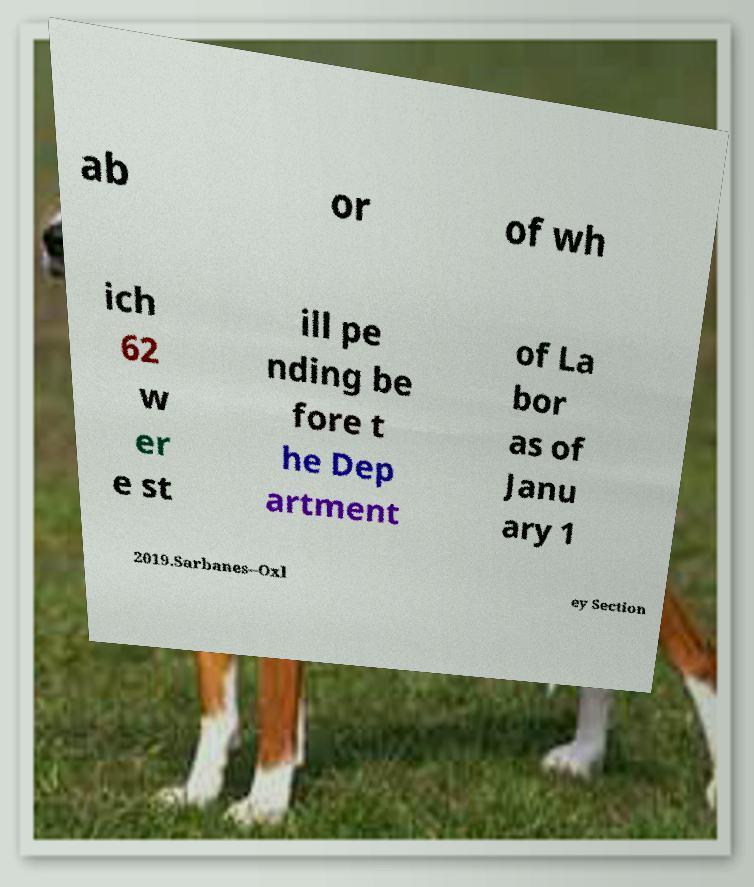There's text embedded in this image that I need extracted. Can you transcribe it verbatim? ab or of wh ich 62 w er e st ill pe nding be fore t he Dep artment of La bor as of Janu ary 1 2019.Sarbanes–Oxl ey Section 